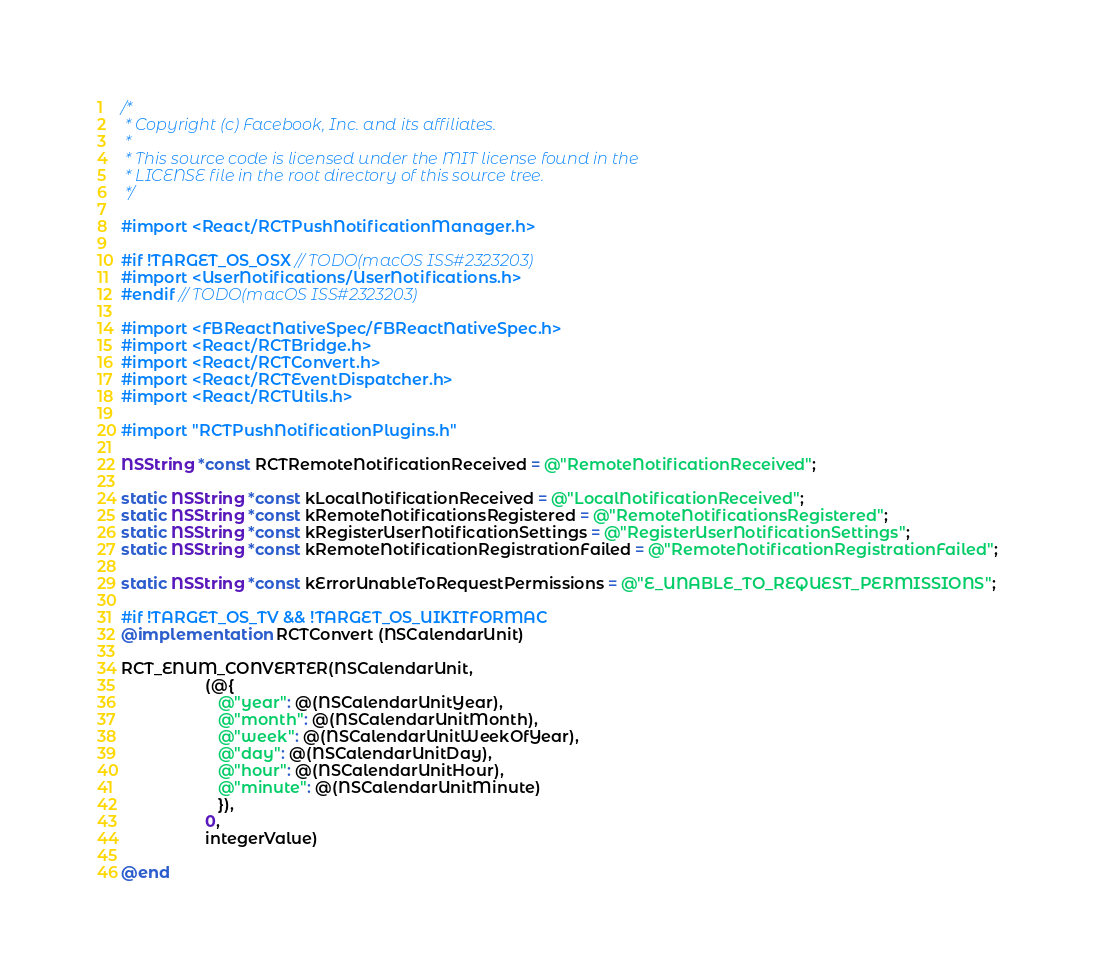<code> <loc_0><loc_0><loc_500><loc_500><_ObjectiveC_>/*
 * Copyright (c) Facebook, Inc. and its affiliates.
 *
 * This source code is licensed under the MIT license found in the
 * LICENSE file in the root directory of this source tree.
 */

#import <React/RCTPushNotificationManager.h>

#if !TARGET_OS_OSX // TODO(macOS ISS#2323203)
#import <UserNotifications/UserNotifications.h>
#endif // TODO(macOS ISS#2323203)

#import <FBReactNativeSpec/FBReactNativeSpec.h>
#import <React/RCTBridge.h>
#import <React/RCTConvert.h>
#import <React/RCTEventDispatcher.h>
#import <React/RCTUtils.h>

#import "RCTPushNotificationPlugins.h"

NSString *const RCTRemoteNotificationReceived = @"RemoteNotificationReceived";

static NSString *const kLocalNotificationReceived = @"LocalNotificationReceived";
static NSString *const kRemoteNotificationsRegistered = @"RemoteNotificationsRegistered";
static NSString *const kRegisterUserNotificationSettings = @"RegisterUserNotificationSettings";
static NSString *const kRemoteNotificationRegistrationFailed = @"RemoteNotificationRegistrationFailed";

static NSString *const kErrorUnableToRequestPermissions = @"E_UNABLE_TO_REQUEST_PERMISSIONS";

#if !TARGET_OS_TV && !TARGET_OS_UIKITFORMAC
@implementation RCTConvert (NSCalendarUnit)

RCT_ENUM_CONVERTER(NSCalendarUnit,
                   (@{
                      @"year": @(NSCalendarUnitYear),
                      @"month": @(NSCalendarUnitMonth),
                      @"week": @(NSCalendarUnitWeekOfYear),
                      @"day": @(NSCalendarUnitDay),
                      @"hour": @(NSCalendarUnitHour),
                      @"minute": @(NSCalendarUnitMinute)
                      }),
                   0,
                   integerValue)

@end
</code> 